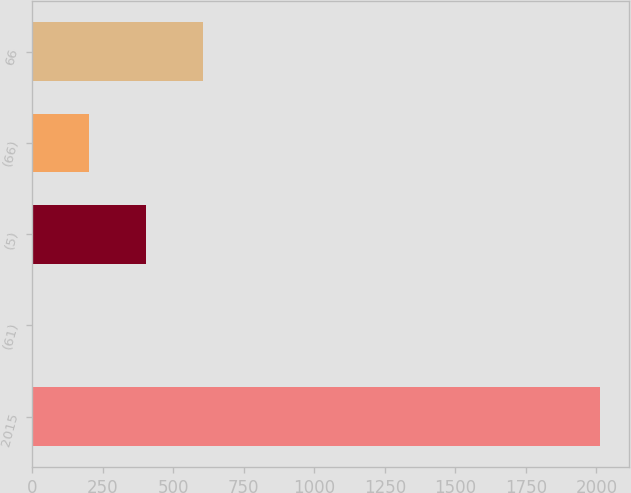Convert chart to OTSL. <chart><loc_0><loc_0><loc_500><loc_500><bar_chart><fcel>2015<fcel>(61)<fcel>(5)<fcel>(66)<fcel>66<nl><fcel>2014<fcel>1<fcel>403.6<fcel>202.3<fcel>604.9<nl></chart> 